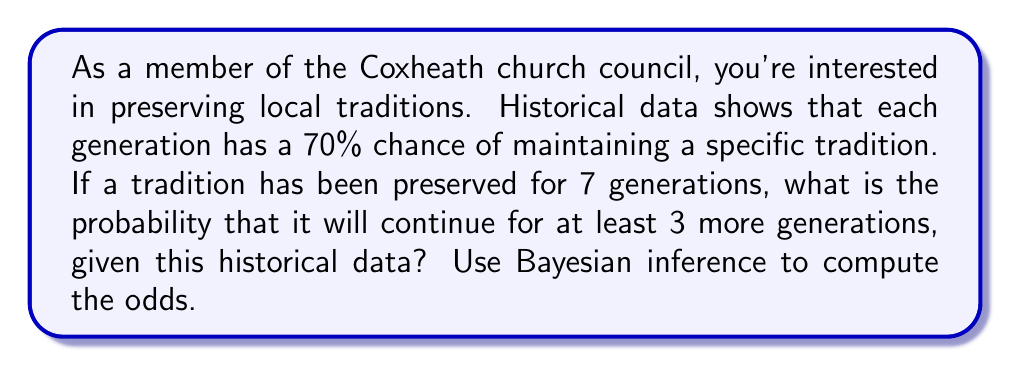Give your solution to this math problem. Let's approach this step-by-step using Bayesian inference:

1) Let A be the event that the tradition continues for at least 3 more generations.
   Let B be the event that the tradition has been preserved for 7 generations.

2) We want to find P(A|B), which is the probability of A given B.

3) Bayes' theorem states:

   $$P(A|B) = \frac{P(B|A) \cdot P(A)}{P(B)}$$

4) We know P(B|A) = 0.7^7, as each generation has a 70% chance of maintaining the tradition.

5) P(A) is the probability of the tradition continuing for at least 3 more generations:
   $$P(A) = 0.7^3 + 0.7^4 \cdot 0.3 + 0.7^5 \cdot 0.3 + ... = 0.7^3 = 0.343$$

6) P(B) is the probability of the tradition being preserved for 7 generations:
   $$P(B) = 0.7^7 = 0.0824$$

7) Substituting into Bayes' theorem:

   $$P(A|B) = \frac{0.7^7 \cdot 0.343}{0.0824} = 0.7^3 = 0.343$$

8) To express this as odds, we calculate:
   $$\text{Odds} = \frac{P(A|B)}{1-P(A|B)} = \frac{0.343}{0.657} \approx 0.522$$

This means the odds are approximately 0.522 to 1, or about 1 to 1.915.
Answer: 0.522 to 1 (or 1 to 1.915) 